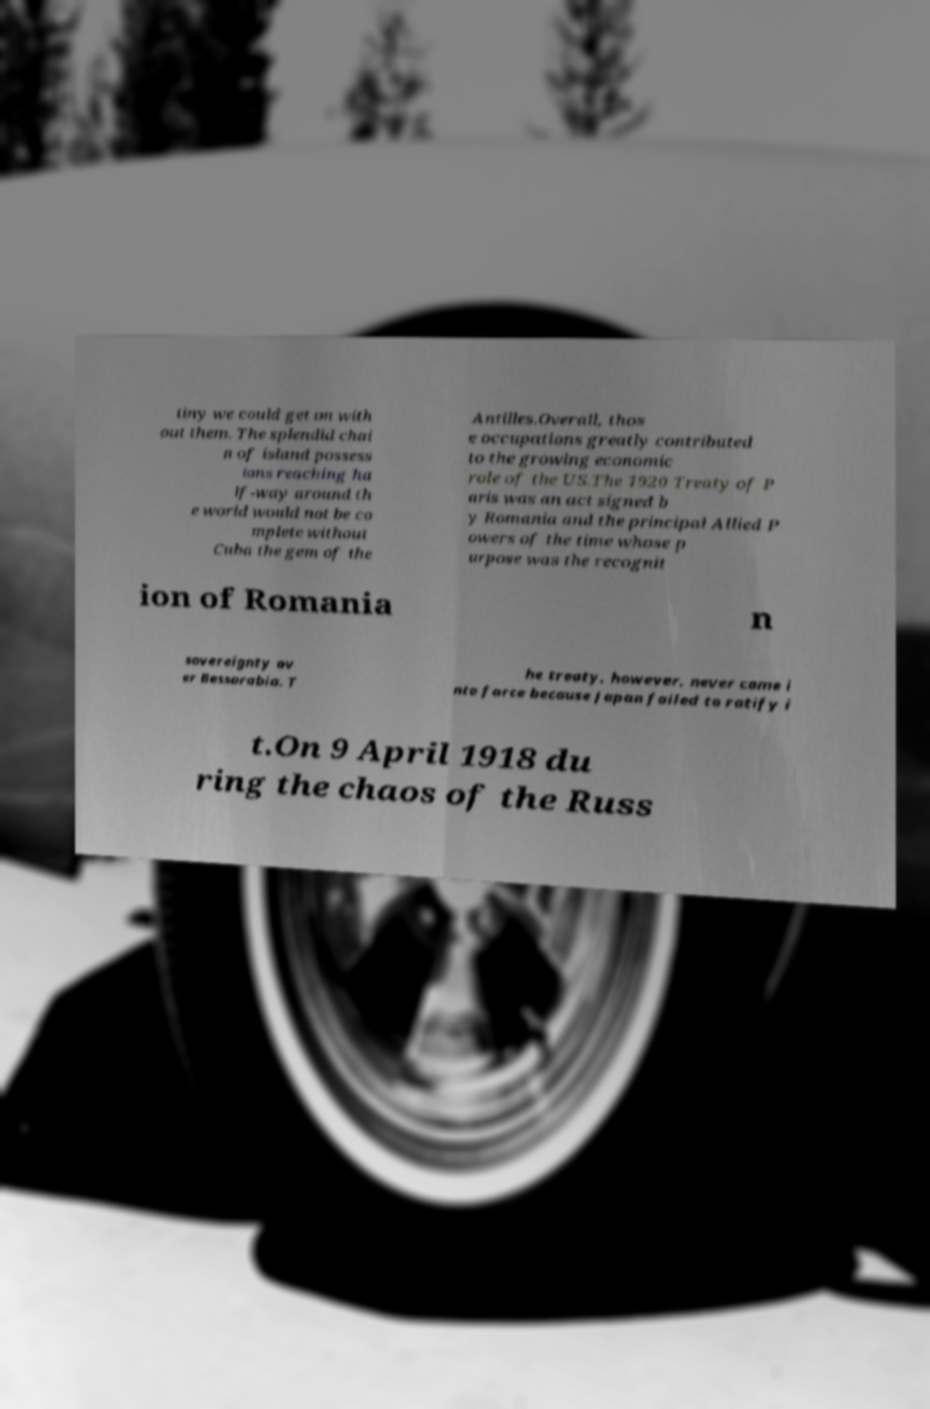Please identify and transcribe the text found in this image. tiny we could get on with out them. The splendid chai n of island possess ions reaching ha lf-way around th e world would not be co mplete without Cuba the gem of the Antilles.Overall, thos e occupations greatly contributed to the growing economic role of the US.The 1920 Treaty of P aris was an act signed b y Romania and the principal Allied P owers of the time whose p urpose was the recognit ion of Romania n sovereignty ov er Bessarabia. T he treaty, however, never came i nto force because Japan failed to ratify i t.On 9 April 1918 du ring the chaos of the Russ 